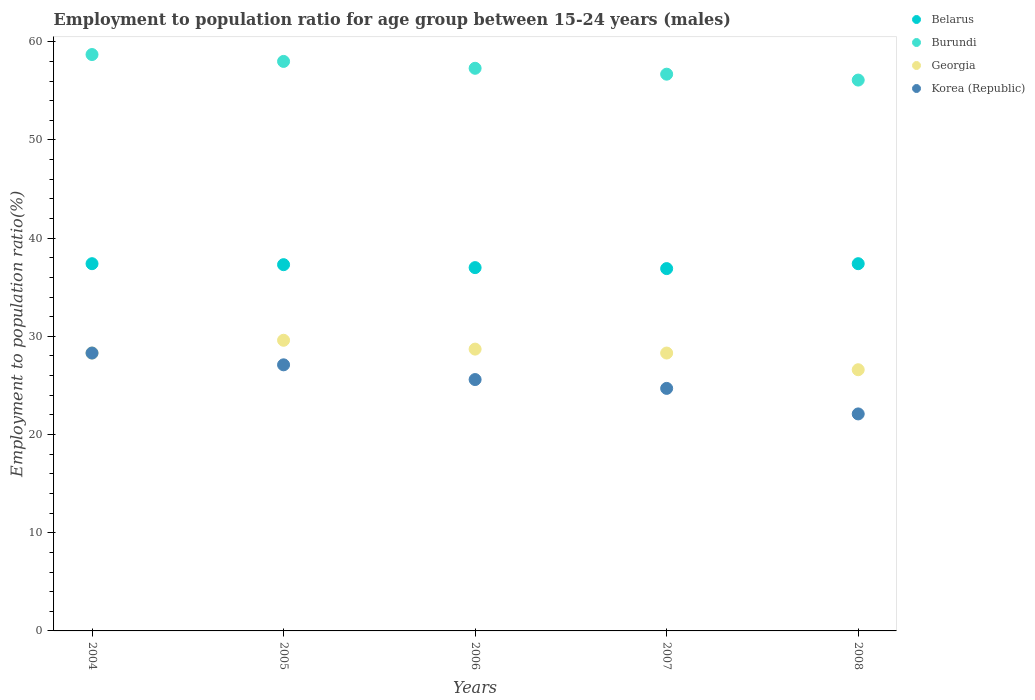What is the employment to population ratio in Burundi in 2006?
Offer a terse response. 57.3. Across all years, what is the maximum employment to population ratio in Korea (Republic)?
Keep it short and to the point. 28.3. Across all years, what is the minimum employment to population ratio in Korea (Republic)?
Provide a succinct answer. 22.1. What is the total employment to population ratio in Burundi in the graph?
Provide a succinct answer. 286.8. What is the difference between the employment to population ratio in Georgia in 2004 and that in 2007?
Your answer should be very brief. 0. What is the difference between the employment to population ratio in Korea (Republic) in 2004 and the employment to population ratio in Belarus in 2008?
Provide a succinct answer. -9.1. What is the average employment to population ratio in Korea (Republic) per year?
Provide a short and direct response. 25.56. In the year 2005, what is the difference between the employment to population ratio in Belarus and employment to population ratio in Georgia?
Keep it short and to the point. 7.7. In how many years, is the employment to population ratio in Belarus greater than 58 %?
Your answer should be very brief. 0. What is the ratio of the employment to population ratio in Burundi in 2004 to that in 2005?
Provide a succinct answer. 1.01. What is the difference between the highest and the second highest employment to population ratio in Burundi?
Keep it short and to the point. 0.7. What is the difference between the highest and the lowest employment to population ratio in Belarus?
Make the answer very short. 0.5. Is it the case that in every year, the sum of the employment to population ratio in Georgia and employment to population ratio in Burundi  is greater than the sum of employment to population ratio in Belarus and employment to population ratio in Korea (Republic)?
Your answer should be very brief. Yes. Is the employment to population ratio in Georgia strictly greater than the employment to population ratio in Belarus over the years?
Your answer should be very brief. No. How many years are there in the graph?
Offer a terse response. 5. Does the graph contain grids?
Keep it short and to the point. No. How many legend labels are there?
Your answer should be very brief. 4. What is the title of the graph?
Offer a terse response. Employment to population ratio for age group between 15-24 years (males). What is the Employment to population ratio(%) in Belarus in 2004?
Make the answer very short. 37.4. What is the Employment to population ratio(%) of Burundi in 2004?
Your answer should be very brief. 58.7. What is the Employment to population ratio(%) in Georgia in 2004?
Provide a short and direct response. 28.3. What is the Employment to population ratio(%) of Korea (Republic) in 2004?
Your answer should be very brief. 28.3. What is the Employment to population ratio(%) in Belarus in 2005?
Give a very brief answer. 37.3. What is the Employment to population ratio(%) of Burundi in 2005?
Provide a short and direct response. 58. What is the Employment to population ratio(%) in Georgia in 2005?
Offer a very short reply. 29.6. What is the Employment to population ratio(%) in Korea (Republic) in 2005?
Give a very brief answer. 27.1. What is the Employment to population ratio(%) in Belarus in 2006?
Offer a very short reply. 37. What is the Employment to population ratio(%) of Burundi in 2006?
Your answer should be compact. 57.3. What is the Employment to population ratio(%) of Georgia in 2006?
Make the answer very short. 28.7. What is the Employment to population ratio(%) of Korea (Republic) in 2006?
Make the answer very short. 25.6. What is the Employment to population ratio(%) of Belarus in 2007?
Your answer should be compact. 36.9. What is the Employment to population ratio(%) of Burundi in 2007?
Give a very brief answer. 56.7. What is the Employment to population ratio(%) of Georgia in 2007?
Your answer should be very brief. 28.3. What is the Employment to population ratio(%) in Korea (Republic) in 2007?
Provide a short and direct response. 24.7. What is the Employment to population ratio(%) of Belarus in 2008?
Offer a very short reply. 37.4. What is the Employment to population ratio(%) of Burundi in 2008?
Keep it short and to the point. 56.1. What is the Employment to population ratio(%) in Georgia in 2008?
Offer a terse response. 26.6. What is the Employment to population ratio(%) of Korea (Republic) in 2008?
Your answer should be very brief. 22.1. Across all years, what is the maximum Employment to population ratio(%) in Belarus?
Provide a short and direct response. 37.4. Across all years, what is the maximum Employment to population ratio(%) in Burundi?
Ensure brevity in your answer.  58.7. Across all years, what is the maximum Employment to population ratio(%) of Georgia?
Your answer should be very brief. 29.6. Across all years, what is the maximum Employment to population ratio(%) of Korea (Republic)?
Keep it short and to the point. 28.3. Across all years, what is the minimum Employment to population ratio(%) in Belarus?
Offer a terse response. 36.9. Across all years, what is the minimum Employment to population ratio(%) in Burundi?
Your answer should be very brief. 56.1. Across all years, what is the minimum Employment to population ratio(%) in Georgia?
Provide a succinct answer. 26.6. Across all years, what is the minimum Employment to population ratio(%) in Korea (Republic)?
Provide a short and direct response. 22.1. What is the total Employment to population ratio(%) of Belarus in the graph?
Give a very brief answer. 186. What is the total Employment to population ratio(%) in Burundi in the graph?
Your response must be concise. 286.8. What is the total Employment to population ratio(%) in Georgia in the graph?
Keep it short and to the point. 141.5. What is the total Employment to population ratio(%) in Korea (Republic) in the graph?
Make the answer very short. 127.8. What is the difference between the Employment to population ratio(%) in Burundi in 2004 and that in 2005?
Provide a short and direct response. 0.7. What is the difference between the Employment to population ratio(%) in Korea (Republic) in 2004 and that in 2005?
Provide a short and direct response. 1.2. What is the difference between the Employment to population ratio(%) of Burundi in 2004 and that in 2006?
Make the answer very short. 1.4. What is the difference between the Employment to population ratio(%) of Georgia in 2004 and that in 2006?
Your answer should be very brief. -0.4. What is the difference between the Employment to population ratio(%) of Korea (Republic) in 2004 and that in 2006?
Ensure brevity in your answer.  2.7. What is the difference between the Employment to population ratio(%) in Belarus in 2004 and that in 2007?
Ensure brevity in your answer.  0.5. What is the difference between the Employment to population ratio(%) of Burundi in 2004 and that in 2007?
Give a very brief answer. 2. What is the difference between the Employment to population ratio(%) in Georgia in 2004 and that in 2007?
Provide a succinct answer. 0. What is the difference between the Employment to population ratio(%) of Korea (Republic) in 2004 and that in 2007?
Offer a terse response. 3.6. What is the difference between the Employment to population ratio(%) of Georgia in 2004 and that in 2008?
Keep it short and to the point. 1.7. What is the difference between the Employment to population ratio(%) of Korea (Republic) in 2004 and that in 2008?
Provide a succinct answer. 6.2. What is the difference between the Employment to population ratio(%) in Georgia in 2005 and that in 2006?
Provide a short and direct response. 0.9. What is the difference between the Employment to population ratio(%) in Korea (Republic) in 2005 and that in 2006?
Give a very brief answer. 1.5. What is the difference between the Employment to population ratio(%) in Burundi in 2005 and that in 2007?
Provide a succinct answer. 1.3. What is the difference between the Employment to population ratio(%) in Georgia in 2005 and that in 2007?
Your response must be concise. 1.3. What is the difference between the Employment to population ratio(%) in Korea (Republic) in 2005 and that in 2007?
Make the answer very short. 2.4. What is the difference between the Employment to population ratio(%) in Georgia in 2005 and that in 2008?
Make the answer very short. 3. What is the difference between the Employment to population ratio(%) of Korea (Republic) in 2005 and that in 2008?
Ensure brevity in your answer.  5. What is the difference between the Employment to population ratio(%) in Burundi in 2006 and that in 2007?
Offer a very short reply. 0.6. What is the difference between the Employment to population ratio(%) in Burundi in 2006 and that in 2008?
Your answer should be very brief. 1.2. What is the difference between the Employment to population ratio(%) in Georgia in 2006 and that in 2008?
Your response must be concise. 2.1. What is the difference between the Employment to population ratio(%) in Belarus in 2007 and that in 2008?
Your answer should be very brief. -0.5. What is the difference between the Employment to population ratio(%) of Burundi in 2007 and that in 2008?
Keep it short and to the point. 0.6. What is the difference between the Employment to population ratio(%) in Belarus in 2004 and the Employment to population ratio(%) in Burundi in 2005?
Provide a succinct answer. -20.6. What is the difference between the Employment to population ratio(%) of Belarus in 2004 and the Employment to population ratio(%) of Korea (Republic) in 2005?
Provide a short and direct response. 10.3. What is the difference between the Employment to population ratio(%) of Burundi in 2004 and the Employment to population ratio(%) of Georgia in 2005?
Your response must be concise. 29.1. What is the difference between the Employment to population ratio(%) of Burundi in 2004 and the Employment to population ratio(%) of Korea (Republic) in 2005?
Your answer should be very brief. 31.6. What is the difference between the Employment to population ratio(%) of Georgia in 2004 and the Employment to population ratio(%) of Korea (Republic) in 2005?
Provide a short and direct response. 1.2. What is the difference between the Employment to population ratio(%) in Belarus in 2004 and the Employment to population ratio(%) in Burundi in 2006?
Your answer should be very brief. -19.9. What is the difference between the Employment to population ratio(%) of Belarus in 2004 and the Employment to population ratio(%) of Georgia in 2006?
Your answer should be compact. 8.7. What is the difference between the Employment to population ratio(%) in Belarus in 2004 and the Employment to population ratio(%) in Korea (Republic) in 2006?
Your response must be concise. 11.8. What is the difference between the Employment to population ratio(%) of Burundi in 2004 and the Employment to population ratio(%) of Korea (Republic) in 2006?
Provide a succinct answer. 33.1. What is the difference between the Employment to population ratio(%) of Georgia in 2004 and the Employment to population ratio(%) of Korea (Republic) in 2006?
Keep it short and to the point. 2.7. What is the difference between the Employment to population ratio(%) in Belarus in 2004 and the Employment to population ratio(%) in Burundi in 2007?
Your response must be concise. -19.3. What is the difference between the Employment to population ratio(%) in Belarus in 2004 and the Employment to population ratio(%) in Georgia in 2007?
Make the answer very short. 9.1. What is the difference between the Employment to population ratio(%) in Belarus in 2004 and the Employment to population ratio(%) in Korea (Republic) in 2007?
Your response must be concise. 12.7. What is the difference between the Employment to population ratio(%) in Burundi in 2004 and the Employment to population ratio(%) in Georgia in 2007?
Your answer should be compact. 30.4. What is the difference between the Employment to population ratio(%) in Georgia in 2004 and the Employment to population ratio(%) in Korea (Republic) in 2007?
Give a very brief answer. 3.6. What is the difference between the Employment to population ratio(%) in Belarus in 2004 and the Employment to population ratio(%) in Burundi in 2008?
Keep it short and to the point. -18.7. What is the difference between the Employment to population ratio(%) in Burundi in 2004 and the Employment to population ratio(%) in Georgia in 2008?
Your answer should be very brief. 32.1. What is the difference between the Employment to population ratio(%) of Burundi in 2004 and the Employment to population ratio(%) of Korea (Republic) in 2008?
Offer a terse response. 36.6. What is the difference between the Employment to population ratio(%) of Georgia in 2004 and the Employment to population ratio(%) of Korea (Republic) in 2008?
Keep it short and to the point. 6.2. What is the difference between the Employment to population ratio(%) in Belarus in 2005 and the Employment to population ratio(%) in Burundi in 2006?
Your answer should be very brief. -20. What is the difference between the Employment to population ratio(%) in Belarus in 2005 and the Employment to population ratio(%) in Georgia in 2006?
Your answer should be very brief. 8.6. What is the difference between the Employment to population ratio(%) of Belarus in 2005 and the Employment to population ratio(%) of Korea (Republic) in 2006?
Make the answer very short. 11.7. What is the difference between the Employment to population ratio(%) in Burundi in 2005 and the Employment to population ratio(%) in Georgia in 2006?
Provide a short and direct response. 29.3. What is the difference between the Employment to population ratio(%) in Burundi in 2005 and the Employment to population ratio(%) in Korea (Republic) in 2006?
Give a very brief answer. 32.4. What is the difference between the Employment to population ratio(%) of Georgia in 2005 and the Employment to population ratio(%) of Korea (Republic) in 2006?
Ensure brevity in your answer.  4. What is the difference between the Employment to population ratio(%) in Belarus in 2005 and the Employment to population ratio(%) in Burundi in 2007?
Your answer should be very brief. -19.4. What is the difference between the Employment to population ratio(%) of Belarus in 2005 and the Employment to population ratio(%) of Georgia in 2007?
Offer a very short reply. 9. What is the difference between the Employment to population ratio(%) of Burundi in 2005 and the Employment to population ratio(%) of Georgia in 2007?
Keep it short and to the point. 29.7. What is the difference between the Employment to population ratio(%) of Burundi in 2005 and the Employment to population ratio(%) of Korea (Republic) in 2007?
Offer a very short reply. 33.3. What is the difference between the Employment to population ratio(%) of Belarus in 2005 and the Employment to population ratio(%) of Burundi in 2008?
Provide a short and direct response. -18.8. What is the difference between the Employment to population ratio(%) of Belarus in 2005 and the Employment to population ratio(%) of Georgia in 2008?
Offer a very short reply. 10.7. What is the difference between the Employment to population ratio(%) in Burundi in 2005 and the Employment to population ratio(%) in Georgia in 2008?
Provide a short and direct response. 31.4. What is the difference between the Employment to population ratio(%) of Burundi in 2005 and the Employment to population ratio(%) of Korea (Republic) in 2008?
Your answer should be very brief. 35.9. What is the difference between the Employment to population ratio(%) in Georgia in 2005 and the Employment to population ratio(%) in Korea (Republic) in 2008?
Make the answer very short. 7.5. What is the difference between the Employment to population ratio(%) of Belarus in 2006 and the Employment to population ratio(%) of Burundi in 2007?
Offer a very short reply. -19.7. What is the difference between the Employment to population ratio(%) in Belarus in 2006 and the Employment to population ratio(%) in Georgia in 2007?
Offer a terse response. 8.7. What is the difference between the Employment to population ratio(%) of Burundi in 2006 and the Employment to population ratio(%) of Korea (Republic) in 2007?
Provide a succinct answer. 32.6. What is the difference between the Employment to population ratio(%) in Georgia in 2006 and the Employment to population ratio(%) in Korea (Republic) in 2007?
Make the answer very short. 4. What is the difference between the Employment to population ratio(%) of Belarus in 2006 and the Employment to population ratio(%) of Burundi in 2008?
Your response must be concise. -19.1. What is the difference between the Employment to population ratio(%) in Belarus in 2006 and the Employment to population ratio(%) in Georgia in 2008?
Offer a very short reply. 10.4. What is the difference between the Employment to population ratio(%) of Belarus in 2006 and the Employment to population ratio(%) of Korea (Republic) in 2008?
Give a very brief answer. 14.9. What is the difference between the Employment to population ratio(%) of Burundi in 2006 and the Employment to population ratio(%) of Georgia in 2008?
Provide a succinct answer. 30.7. What is the difference between the Employment to population ratio(%) of Burundi in 2006 and the Employment to population ratio(%) of Korea (Republic) in 2008?
Your answer should be compact. 35.2. What is the difference between the Employment to population ratio(%) in Belarus in 2007 and the Employment to population ratio(%) in Burundi in 2008?
Provide a short and direct response. -19.2. What is the difference between the Employment to population ratio(%) of Belarus in 2007 and the Employment to population ratio(%) of Georgia in 2008?
Your answer should be compact. 10.3. What is the difference between the Employment to population ratio(%) in Burundi in 2007 and the Employment to population ratio(%) in Georgia in 2008?
Provide a succinct answer. 30.1. What is the difference between the Employment to population ratio(%) of Burundi in 2007 and the Employment to population ratio(%) of Korea (Republic) in 2008?
Provide a short and direct response. 34.6. What is the difference between the Employment to population ratio(%) of Georgia in 2007 and the Employment to population ratio(%) of Korea (Republic) in 2008?
Provide a succinct answer. 6.2. What is the average Employment to population ratio(%) in Belarus per year?
Make the answer very short. 37.2. What is the average Employment to population ratio(%) in Burundi per year?
Your answer should be compact. 57.36. What is the average Employment to population ratio(%) in Georgia per year?
Ensure brevity in your answer.  28.3. What is the average Employment to population ratio(%) of Korea (Republic) per year?
Make the answer very short. 25.56. In the year 2004, what is the difference between the Employment to population ratio(%) in Belarus and Employment to population ratio(%) in Burundi?
Give a very brief answer. -21.3. In the year 2004, what is the difference between the Employment to population ratio(%) in Burundi and Employment to population ratio(%) in Georgia?
Keep it short and to the point. 30.4. In the year 2004, what is the difference between the Employment to population ratio(%) of Burundi and Employment to population ratio(%) of Korea (Republic)?
Make the answer very short. 30.4. In the year 2004, what is the difference between the Employment to population ratio(%) in Georgia and Employment to population ratio(%) in Korea (Republic)?
Your answer should be very brief. 0. In the year 2005, what is the difference between the Employment to population ratio(%) of Belarus and Employment to population ratio(%) of Burundi?
Provide a succinct answer. -20.7. In the year 2005, what is the difference between the Employment to population ratio(%) in Belarus and Employment to population ratio(%) in Georgia?
Your answer should be compact. 7.7. In the year 2005, what is the difference between the Employment to population ratio(%) of Burundi and Employment to population ratio(%) of Georgia?
Your answer should be very brief. 28.4. In the year 2005, what is the difference between the Employment to population ratio(%) in Burundi and Employment to population ratio(%) in Korea (Republic)?
Make the answer very short. 30.9. In the year 2005, what is the difference between the Employment to population ratio(%) of Georgia and Employment to population ratio(%) of Korea (Republic)?
Make the answer very short. 2.5. In the year 2006, what is the difference between the Employment to population ratio(%) of Belarus and Employment to population ratio(%) of Burundi?
Your answer should be very brief. -20.3. In the year 2006, what is the difference between the Employment to population ratio(%) of Belarus and Employment to population ratio(%) of Korea (Republic)?
Give a very brief answer. 11.4. In the year 2006, what is the difference between the Employment to population ratio(%) in Burundi and Employment to population ratio(%) in Georgia?
Your response must be concise. 28.6. In the year 2006, what is the difference between the Employment to population ratio(%) of Burundi and Employment to population ratio(%) of Korea (Republic)?
Keep it short and to the point. 31.7. In the year 2007, what is the difference between the Employment to population ratio(%) in Belarus and Employment to population ratio(%) in Burundi?
Your answer should be compact. -19.8. In the year 2007, what is the difference between the Employment to population ratio(%) in Burundi and Employment to population ratio(%) in Georgia?
Offer a terse response. 28.4. In the year 2007, what is the difference between the Employment to population ratio(%) in Burundi and Employment to population ratio(%) in Korea (Republic)?
Provide a short and direct response. 32. In the year 2008, what is the difference between the Employment to population ratio(%) in Belarus and Employment to population ratio(%) in Burundi?
Your answer should be very brief. -18.7. In the year 2008, what is the difference between the Employment to population ratio(%) in Belarus and Employment to population ratio(%) in Georgia?
Ensure brevity in your answer.  10.8. In the year 2008, what is the difference between the Employment to population ratio(%) in Burundi and Employment to population ratio(%) in Georgia?
Make the answer very short. 29.5. In the year 2008, what is the difference between the Employment to population ratio(%) of Burundi and Employment to population ratio(%) of Korea (Republic)?
Your answer should be compact. 34. In the year 2008, what is the difference between the Employment to population ratio(%) of Georgia and Employment to population ratio(%) of Korea (Republic)?
Ensure brevity in your answer.  4.5. What is the ratio of the Employment to population ratio(%) of Burundi in 2004 to that in 2005?
Make the answer very short. 1.01. What is the ratio of the Employment to population ratio(%) of Georgia in 2004 to that in 2005?
Your response must be concise. 0.96. What is the ratio of the Employment to population ratio(%) in Korea (Republic) in 2004 to that in 2005?
Offer a very short reply. 1.04. What is the ratio of the Employment to population ratio(%) in Belarus in 2004 to that in 2006?
Provide a short and direct response. 1.01. What is the ratio of the Employment to population ratio(%) of Burundi in 2004 to that in 2006?
Ensure brevity in your answer.  1.02. What is the ratio of the Employment to population ratio(%) of Georgia in 2004 to that in 2006?
Offer a terse response. 0.99. What is the ratio of the Employment to population ratio(%) of Korea (Republic) in 2004 to that in 2006?
Offer a terse response. 1.11. What is the ratio of the Employment to population ratio(%) in Belarus in 2004 to that in 2007?
Offer a very short reply. 1.01. What is the ratio of the Employment to population ratio(%) of Burundi in 2004 to that in 2007?
Ensure brevity in your answer.  1.04. What is the ratio of the Employment to population ratio(%) of Georgia in 2004 to that in 2007?
Keep it short and to the point. 1. What is the ratio of the Employment to population ratio(%) of Korea (Republic) in 2004 to that in 2007?
Offer a very short reply. 1.15. What is the ratio of the Employment to population ratio(%) of Burundi in 2004 to that in 2008?
Keep it short and to the point. 1.05. What is the ratio of the Employment to population ratio(%) of Georgia in 2004 to that in 2008?
Your answer should be very brief. 1.06. What is the ratio of the Employment to population ratio(%) in Korea (Republic) in 2004 to that in 2008?
Make the answer very short. 1.28. What is the ratio of the Employment to population ratio(%) of Burundi in 2005 to that in 2006?
Your answer should be very brief. 1.01. What is the ratio of the Employment to population ratio(%) of Georgia in 2005 to that in 2006?
Your response must be concise. 1.03. What is the ratio of the Employment to population ratio(%) of Korea (Republic) in 2005 to that in 2006?
Your answer should be very brief. 1.06. What is the ratio of the Employment to population ratio(%) in Belarus in 2005 to that in 2007?
Your answer should be very brief. 1.01. What is the ratio of the Employment to population ratio(%) in Burundi in 2005 to that in 2007?
Your answer should be very brief. 1.02. What is the ratio of the Employment to population ratio(%) in Georgia in 2005 to that in 2007?
Keep it short and to the point. 1.05. What is the ratio of the Employment to population ratio(%) in Korea (Republic) in 2005 to that in 2007?
Make the answer very short. 1.1. What is the ratio of the Employment to population ratio(%) of Burundi in 2005 to that in 2008?
Offer a terse response. 1.03. What is the ratio of the Employment to population ratio(%) of Georgia in 2005 to that in 2008?
Provide a short and direct response. 1.11. What is the ratio of the Employment to population ratio(%) in Korea (Republic) in 2005 to that in 2008?
Your answer should be compact. 1.23. What is the ratio of the Employment to population ratio(%) in Burundi in 2006 to that in 2007?
Ensure brevity in your answer.  1.01. What is the ratio of the Employment to population ratio(%) of Georgia in 2006 to that in 2007?
Provide a succinct answer. 1.01. What is the ratio of the Employment to population ratio(%) in Korea (Republic) in 2006 to that in 2007?
Your answer should be compact. 1.04. What is the ratio of the Employment to population ratio(%) of Belarus in 2006 to that in 2008?
Offer a very short reply. 0.99. What is the ratio of the Employment to population ratio(%) of Burundi in 2006 to that in 2008?
Your response must be concise. 1.02. What is the ratio of the Employment to population ratio(%) of Georgia in 2006 to that in 2008?
Your answer should be compact. 1.08. What is the ratio of the Employment to population ratio(%) in Korea (Republic) in 2006 to that in 2008?
Ensure brevity in your answer.  1.16. What is the ratio of the Employment to population ratio(%) of Belarus in 2007 to that in 2008?
Your answer should be very brief. 0.99. What is the ratio of the Employment to population ratio(%) in Burundi in 2007 to that in 2008?
Ensure brevity in your answer.  1.01. What is the ratio of the Employment to population ratio(%) of Georgia in 2007 to that in 2008?
Keep it short and to the point. 1.06. What is the ratio of the Employment to population ratio(%) of Korea (Republic) in 2007 to that in 2008?
Give a very brief answer. 1.12. What is the difference between the highest and the second highest Employment to population ratio(%) in Belarus?
Make the answer very short. 0. What is the difference between the highest and the second highest Employment to population ratio(%) in Georgia?
Provide a short and direct response. 0.9. What is the difference between the highest and the lowest Employment to population ratio(%) in Belarus?
Ensure brevity in your answer.  0.5. What is the difference between the highest and the lowest Employment to population ratio(%) in Burundi?
Offer a very short reply. 2.6. What is the difference between the highest and the lowest Employment to population ratio(%) of Korea (Republic)?
Your answer should be very brief. 6.2. 